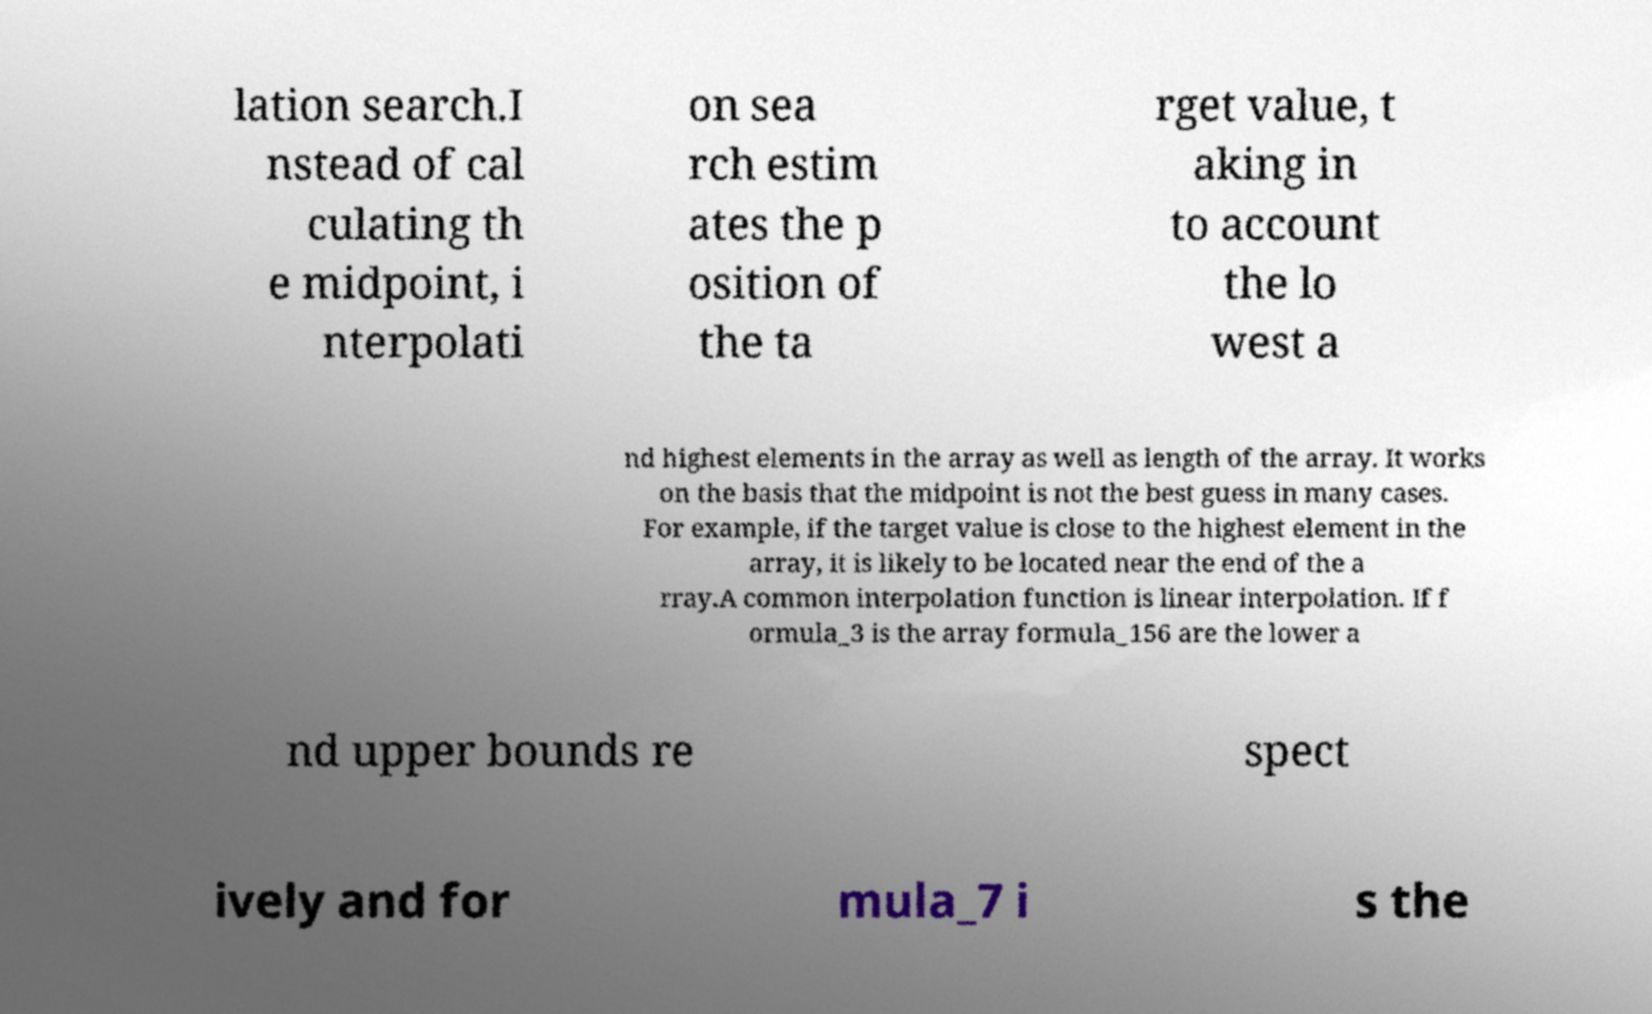I need the written content from this picture converted into text. Can you do that? lation search.I nstead of cal culating th e midpoint, i nterpolati on sea rch estim ates the p osition of the ta rget value, t aking in to account the lo west a nd highest elements in the array as well as length of the array. It works on the basis that the midpoint is not the best guess in many cases. For example, if the target value is close to the highest element in the array, it is likely to be located near the end of the a rray.A common interpolation function is linear interpolation. If f ormula_3 is the array formula_156 are the lower a nd upper bounds re spect ively and for mula_7 i s the 